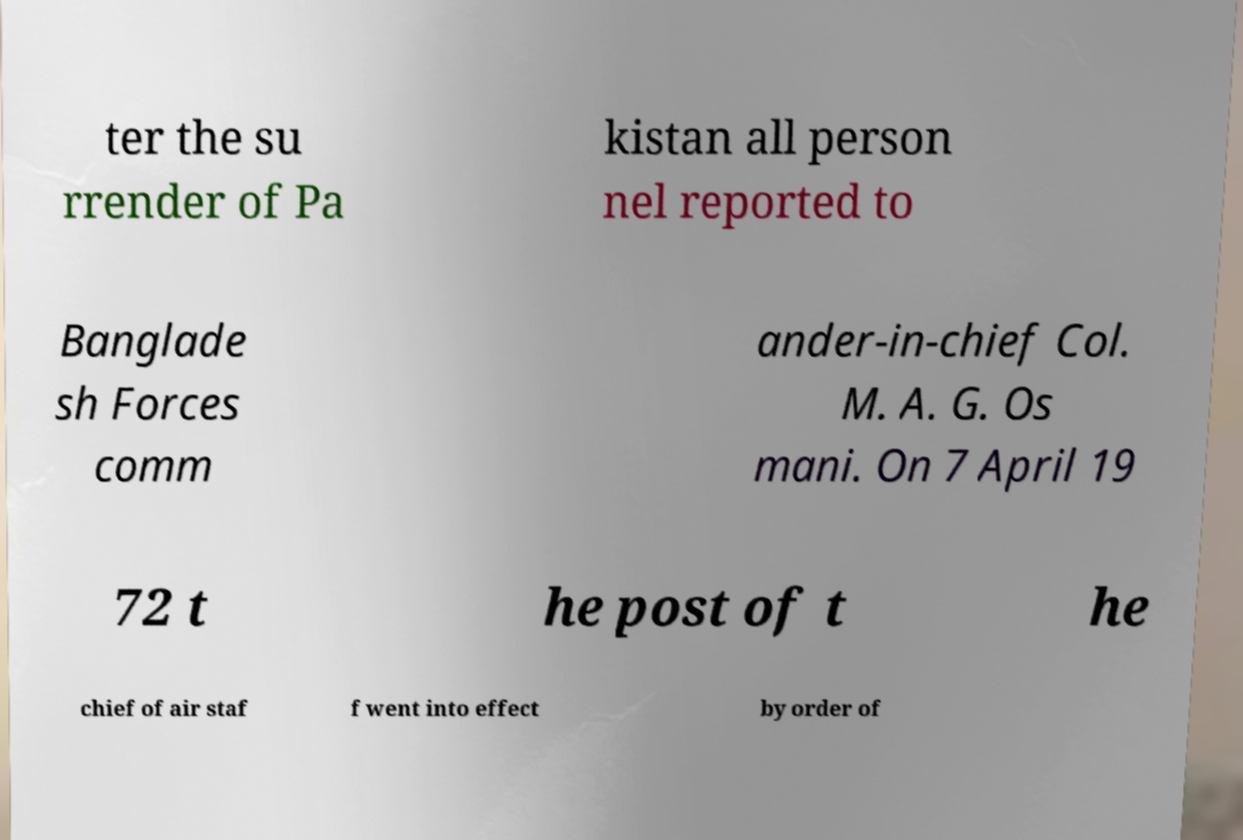There's text embedded in this image that I need extracted. Can you transcribe it verbatim? ter the su rrender of Pa kistan all person nel reported to Banglade sh Forces comm ander-in-chief Col. M. A. G. Os mani. On 7 April 19 72 t he post of t he chief of air staf f went into effect by order of 